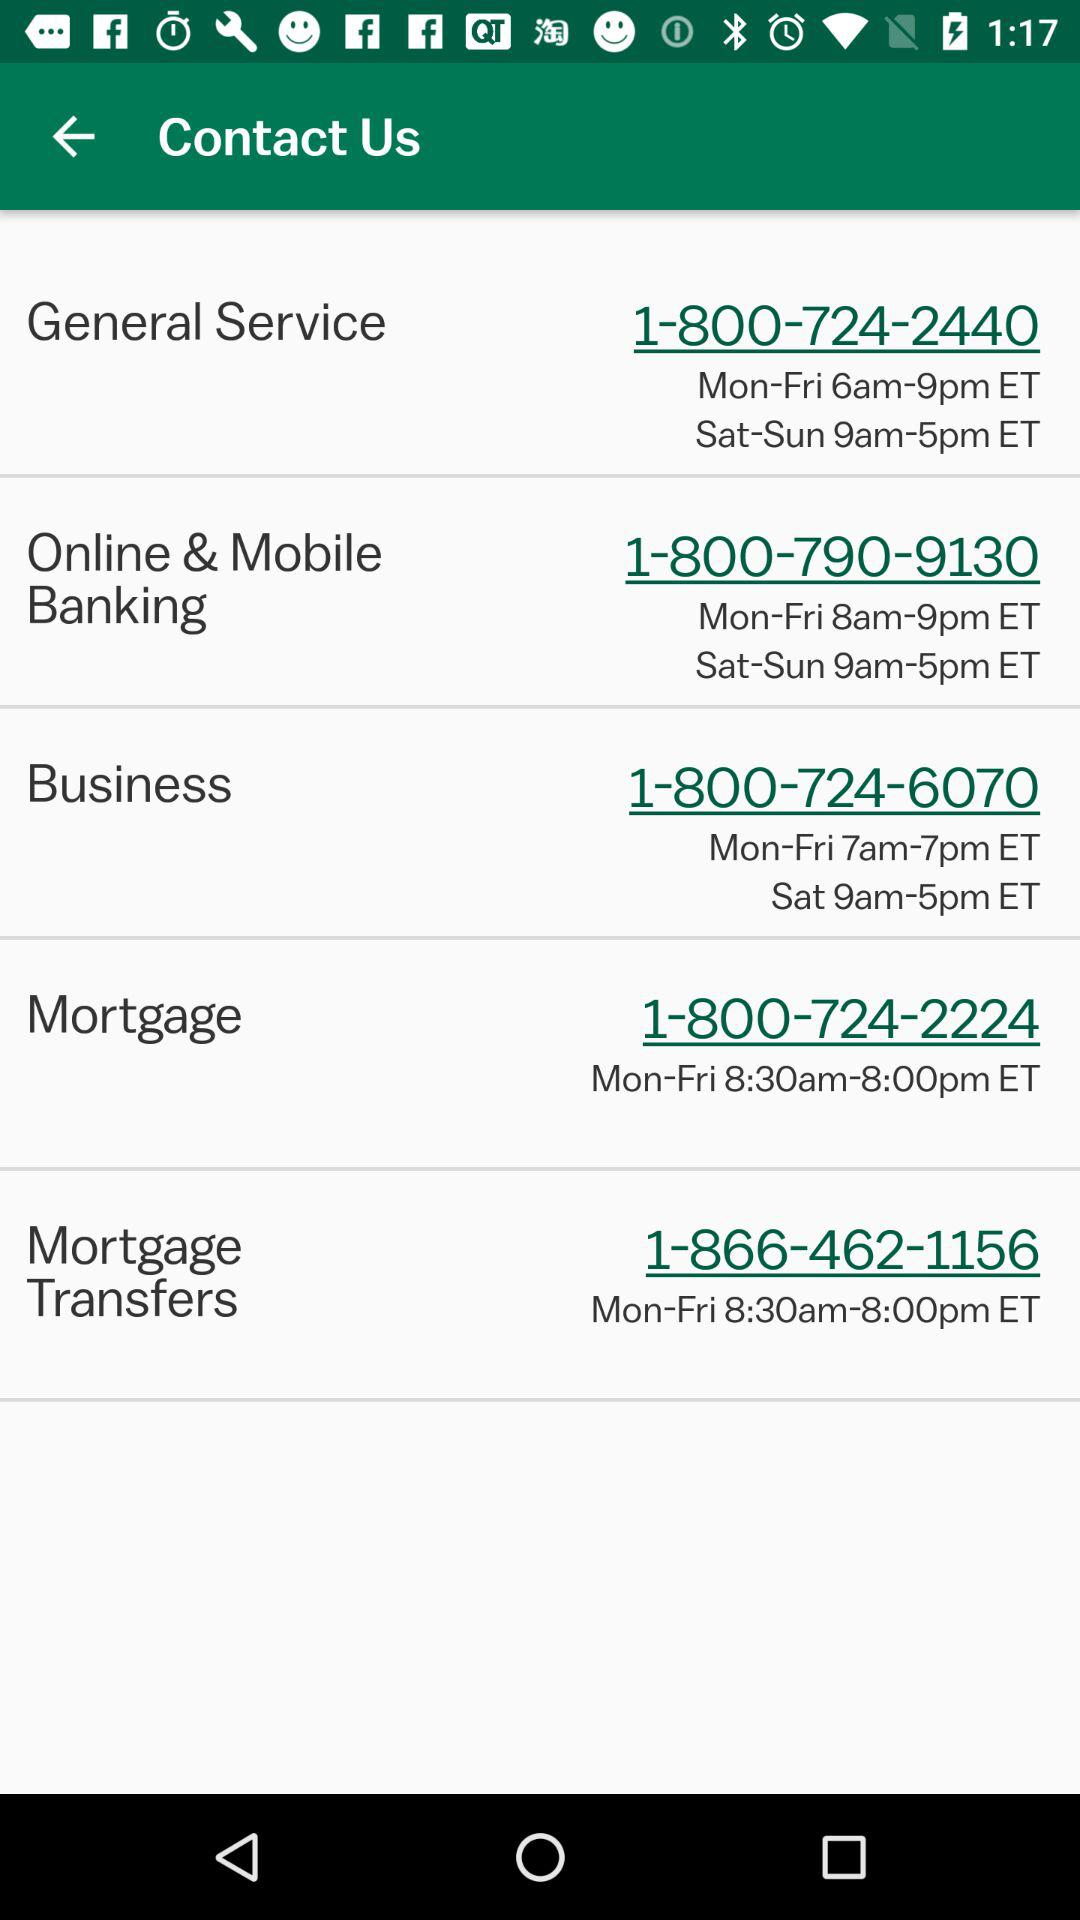What time is given for the weekend in business? The time given for the weekend in business is 9am-5pm ET. 